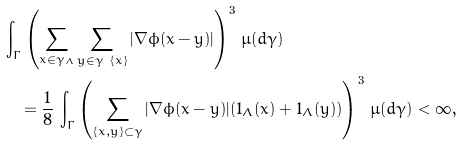<formula> <loc_0><loc_0><loc_500><loc_500>& \int _ { \Gamma } \left ( \sum _ { x \in \gamma _ { \Lambda } } \sum _ { y \in \gamma \ \{ x \} } | \nabla \phi ( x - y ) | \right ) ^ { 3 } \, \mu ( d \gamma ) \\ & \quad = \frac { 1 } { 8 } \, \int _ { \Gamma } \left ( \sum _ { \{ x , y \} \subset \gamma } | \nabla \phi ( x - y ) | ( { 1 } _ { \Lambda } ( x ) + { 1 } _ { \Lambda } ( y ) ) \right ) ^ { 3 } \, \mu ( d \gamma ) < \infty ,</formula> 